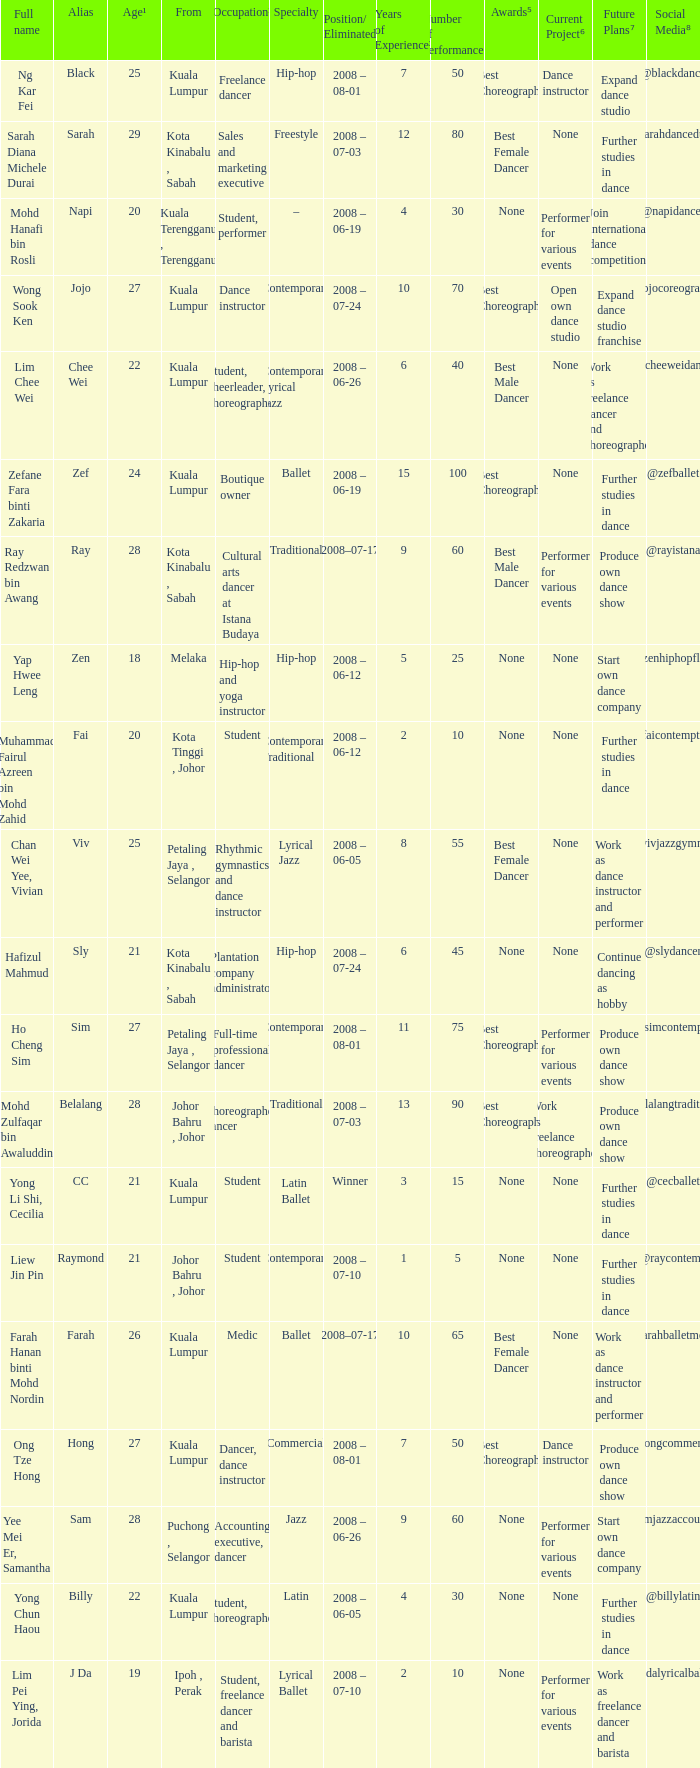What is Position/ Eliminated, when Age¹ is less than 22, and when Full Name is "Muhammad Fairul Azreen Bin Mohd Zahid"? 2008 – 06-12. 